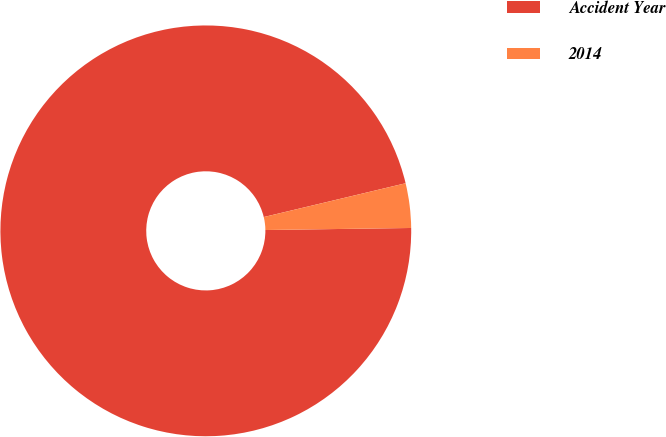Convert chart to OTSL. <chart><loc_0><loc_0><loc_500><loc_500><pie_chart><fcel>Accident Year<fcel>2014<nl><fcel>96.5%<fcel>3.5%<nl></chart> 